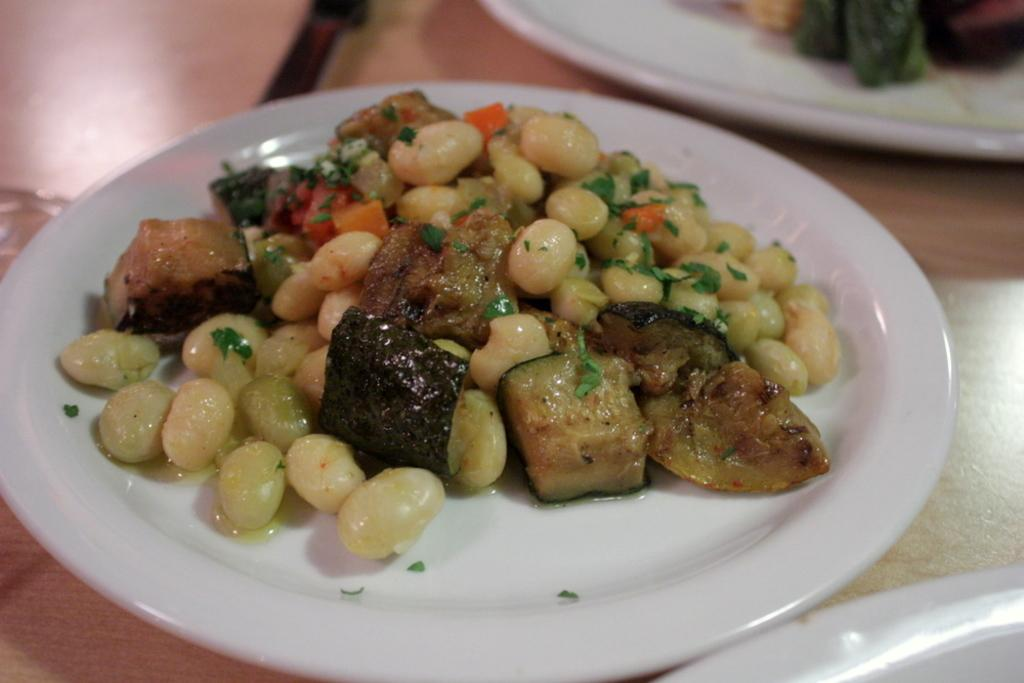What is on the plate that is visible in the image? There are food items on a plate in the image. Where is the plate located in the image? The plate is placed on a table. How many eggs are visible on the plate in the image? There is no mention of eggs in the image, so we cannot determine the number of eggs present. 